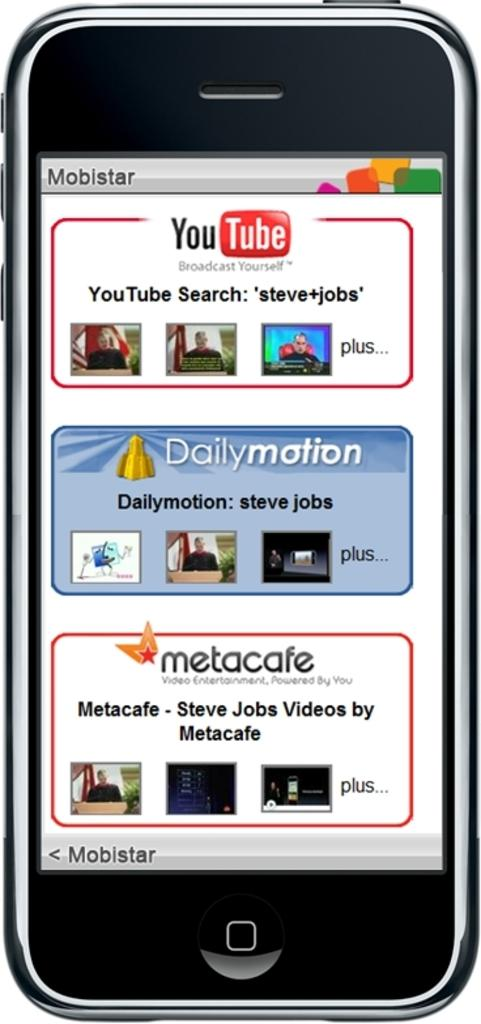<image>
Describe the image concisely. A simulated screen of an iPhone running Mobistar search engine. 